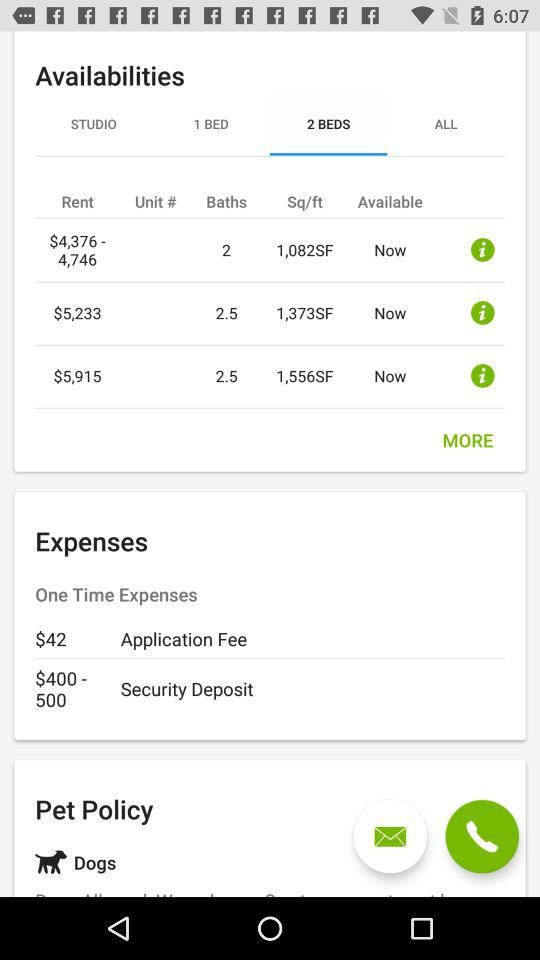What is the security deposit? The security deposit is $400 to $500. 